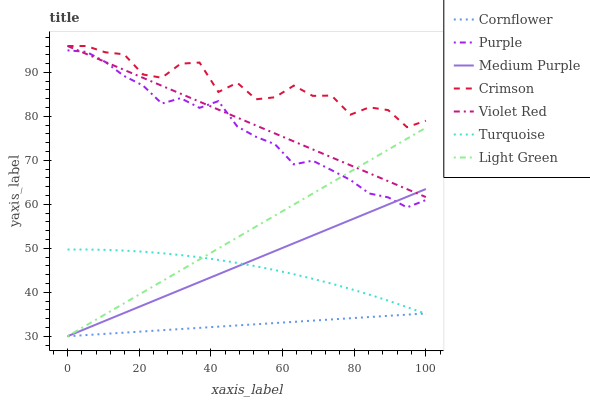Does Cornflower have the minimum area under the curve?
Answer yes or no. Yes. Does Crimson have the maximum area under the curve?
Answer yes or no. Yes. Does Turquoise have the minimum area under the curve?
Answer yes or no. No. Does Turquoise have the maximum area under the curve?
Answer yes or no. No. Is Cornflower the smoothest?
Answer yes or no. Yes. Is Crimson the roughest?
Answer yes or no. Yes. Is Turquoise the smoothest?
Answer yes or no. No. Is Turquoise the roughest?
Answer yes or no. No. Does Cornflower have the lowest value?
Answer yes or no. Yes. Does Turquoise have the lowest value?
Answer yes or no. No. Does Crimson have the highest value?
Answer yes or no. Yes. Does Turquoise have the highest value?
Answer yes or no. No. Is Cornflower less than Crimson?
Answer yes or no. Yes. Is Purple greater than Cornflower?
Answer yes or no. Yes. Does Crimson intersect Violet Red?
Answer yes or no. Yes. Is Crimson less than Violet Red?
Answer yes or no. No. Is Crimson greater than Violet Red?
Answer yes or no. No. Does Cornflower intersect Crimson?
Answer yes or no. No. 